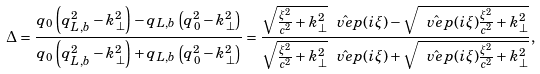<formula> <loc_0><loc_0><loc_500><loc_500>\Delta = \frac { q _ { 0 } \left ( q _ { L , b } ^ { 2 } - k _ { \perp } ^ { 2 } \right ) - q _ { L , b } \left ( q _ { 0 } ^ { 2 } - k _ { \perp } ^ { 2 } \right ) } { q _ { 0 } \left ( q _ { L , b } ^ { 2 } - k _ { \perp } ^ { 2 } \right ) + q _ { L , b } \left ( q _ { 0 } ^ { 2 } - k _ { \perp } ^ { 2 } \right ) } = \frac { \sqrt { \frac { \xi ^ { 2 } } { c ^ { 2 } } + k _ { \perp } ^ { 2 } } \hat { \ v e p } ( i \xi ) - \sqrt { \hat { \ v e p } ( i \xi ) \frac { \xi ^ { 2 } } { c ^ { 2 } } + k _ { \perp } ^ { 2 } } } { \sqrt { \frac { \xi ^ { 2 } } { c ^ { 2 } } + k _ { \perp } ^ { 2 } } \hat { \ v e p } ( i \xi ) + \sqrt { \hat { \ v e p } ( i \xi ) \frac { \xi ^ { 2 } } { c ^ { 2 } } + k _ { \perp } ^ { 2 } } } ,</formula> 